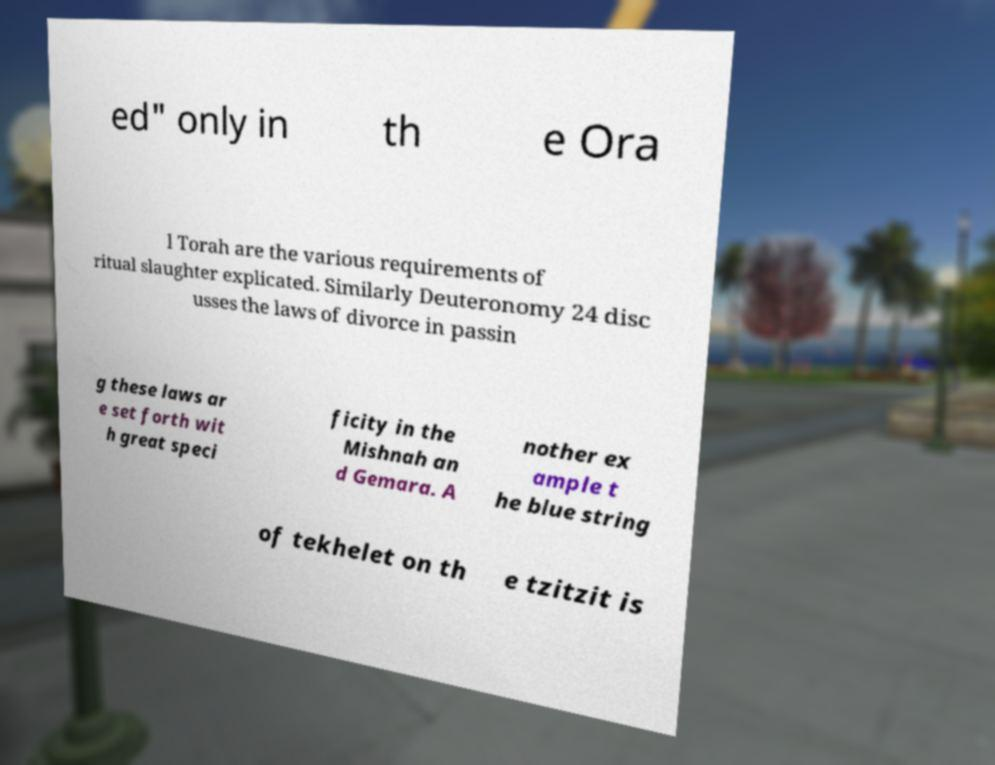There's text embedded in this image that I need extracted. Can you transcribe it verbatim? ed" only in th e Ora l Torah are the various requirements of ritual slaughter explicated. Similarly Deuteronomy 24 disc usses the laws of divorce in passin g these laws ar e set forth wit h great speci ficity in the Mishnah an d Gemara. A nother ex ample t he blue string of tekhelet on th e tzitzit is 